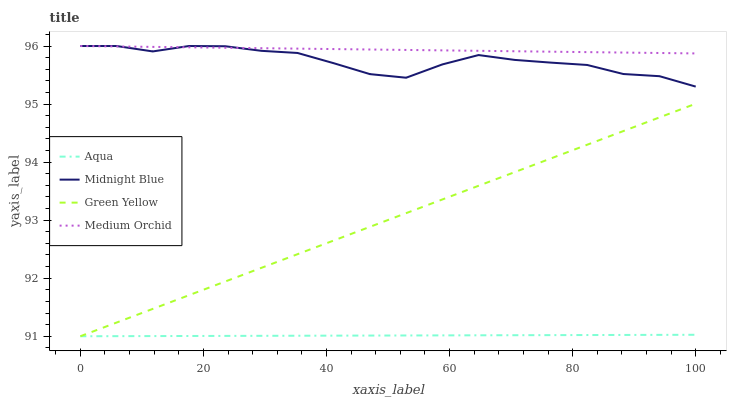Does Aqua have the minimum area under the curve?
Answer yes or no. Yes. Does Medium Orchid have the maximum area under the curve?
Answer yes or no. Yes. Does Green Yellow have the minimum area under the curve?
Answer yes or no. No. Does Green Yellow have the maximum area under the curve?
Answer yes or no. No. Is Medium Orchid the smoothest?
Answer yes or no. Yes. Is Midnight Blue the roughest?
Answer yes or no. Yes. Is Green Yellow the smoothest?
Answer yes or no. No. Is Green Yellow the roughest?
Answer yes or no. No. Does Green Yellow have the lowest value?
Answer yes or no. Yes. Does Midnight Blue have the lowest value?
Answer yes or no. No. Does Midnight Blue have the highest value?
Answer yes or no. Yes. Does Green Yellow have the highest value?
Answer yes or no. No. Is Green Yellow less than Midnight Blue?
Answer yes or no. Yes. Is Midnight Blue greater than Aqua?
Answer yes or no. Yes. Does Medium Orchid intersect Midnight Blue?
Answer yes or no. Yes. Is Medium Orchid less than Midnight Blue?
Answer yes or no. No. Is Medium Orchid greater than Midnight Blue?
Answer yes or no. No. Does Green Yellow intersect Midnight Blue?
Answer yes or no. No. 